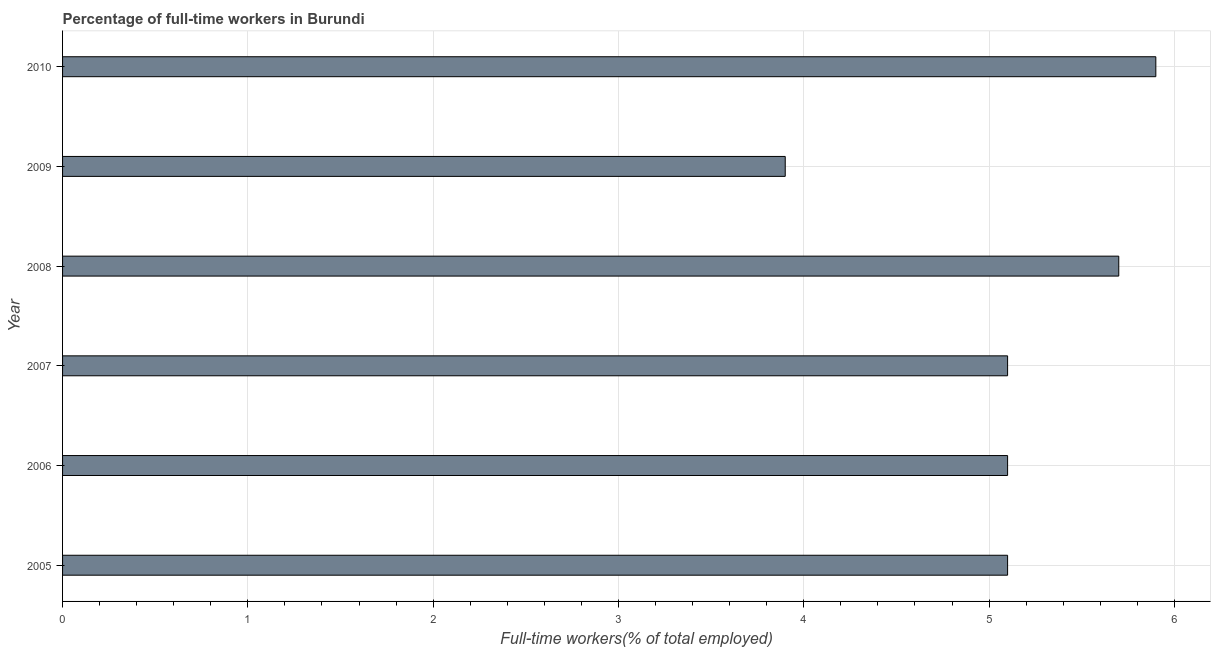Does the graph contain grids?
Your response must be concise. Yes. What is the title of the graph?
Provide a succinct answer. Percentage of full-time workers in Burundi. What is the label or title of the X-axis?
Make the answer very short. Full-time workers(% of total employed). What is the label or title of the Y-axis?
Make the answer very short. Year. What is the percentage of full-time workers in 2007?
Offer a terse response. 5.1. Across all years, what is the maximum percentage of full-time workers?
Keep it short and to the point. 5.9. Across all years, what is the minimum percentage of full-time workers?
Your answer should be very brief. 3.9. What is the sum of the percentage of full-time workers?
Your answer should be very brief. 30.8. What is the average percentage of full-time workers per year?
Keep it short and to the point. 5.13. What is the median percentage of full-time workers?
Your answer should be compact. 5.1. What is the ratio of the percentage of full-time workers in 2006 to that in 2007?
Offer a very short reply. 1. Is the difference between the percentage of full-time workers in 2005 and 2006 greater than the difference between any two years?
Give a very brief answer. No. In how many years, is the percentage of full-time workers greater than the average percentage of full-time workers taken over all years?
Make the answer very short. 2. How many bars are there?
Give a very brief answer. 6. Are all the bars in the graph horizontal?
Provide a short and direct response. Yes. How many years are there in the graph?
Your response must be concise. 6. What is the Full-time workers(% of total employed) of 2005?
Keep it short and to the point. 5.1. What is the Full-time workers(% of total employed) of 2006?
Provide a succinct answer. 5.1. What is the Full-time workers(% of total employed) of 2007?
Offer a terse response. 5.1. What is the Full-time workers(% of total employed) of 2008?
Keep it short and to the point. 5.7. What is the Full-time workers(% of total employed) in 2009?
Offer a very short reply. 3.9. What is the Full-time workers(% of total employed) of 2010?
Your answer should be very brief. 5.9. What is the difference between the Full-time workers(% of total employed) in 2005 and 2006?
Your response must be concise. 0. What is the difference between the Full-time workers(% of total employed) in 2005 and 2009?
Provide a short and direct response. 1.2. What is the difference between the Full-time workers(% of total employed) in 2005 and 2010?
Ensure brevity in your answer.  -0.8. What is the difference between the Full-time workers(% of total employed) in 2008 and 2009?
Offer a terse response. 1.8. What is the difference between the Full-time workers(% of total employed) in 2008 and 2010?
Give a very brief answer. -0.2. What is the difference between the Full-time workers(% of total employed) in 2009 and 2010?
Give a very brief answer. -2. What is the ratio of the Full-time workers(% of total employed) in 2005 to that in 2006?
Provide a short and direct response. 1. What is the ratio of the Full-time workers(% of total employed) in 2005 to that in 2007?
Make the answer very short. 1. What is the ratio of the Full-time workers(% of total employed) in 2005 to that in 2008?
Provide a short and direct response. 0.9. What is the ratio of the Full-time workers(% of total employed) in 2005 to that in 2009?
Your response must be concise. 1.31. What is the ratio of the Full-time workers(% of total employed) in 2005 to that in 2010?
Offer a very short reply. 0.86. What is the ratio of the Full-time workers(% of total employed) in 2006 to that in 2007?
Your response must be concise. 1. What is the ratio of the Full-time workers(% of total employed) in 2006 to that in 2008?
Offer a terse response. 0.9. What is the ratio of the Full-time workers(% of total employed) in 2006 to that in 2009?
Offer a terse response. 1.31. What is the ratio of the Full-time workers(% of total employed) in 2006 to that in 2010?
Your answer should be very brief. 0.86. What is the ratio of the Full-time workers(% of total employed) in 2007 to that in 2008?
Offer a very short reply. 0.9. What is the ratio of the Full-time workers(% of total employed) in 2007 to that in 2009?
Give a very brief answer. 1.31. What is the ratio of the Full-time workers(% of total employed) in 2007 to that in 2010?
Ensure brevity in your answer.  0.86. What is the ratio of the Full-time workers(% of total employed) in 2008 to that in 2009?
Your response must be concise. 1.46. What is the ratio of the Full-time workers(% of total employed) in 2009 to that in 2010?
Offer a terse response. 0.66. 